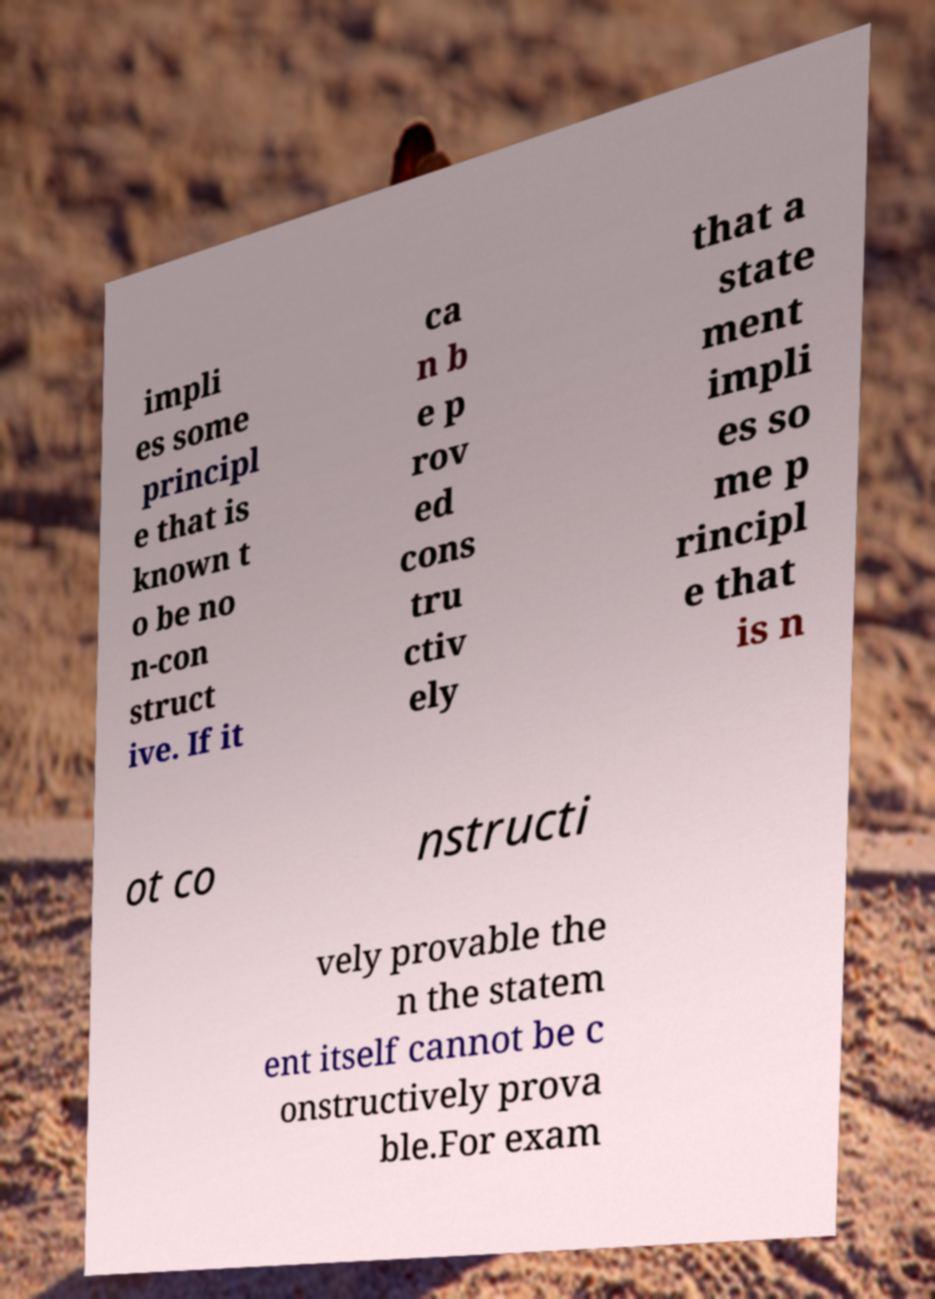For documentation purposes, I need the text within this image transcribed. Could you provide that? impli es some principl e that is known t o be no n-con struct ive. If it ca n b e p rov ed cons tru ctiv ely that a state ment impli es so me p rincipl e that is n ot co nstructi vely provable the n the statem ent itself cannot be c onstructively prova ble.For exam 